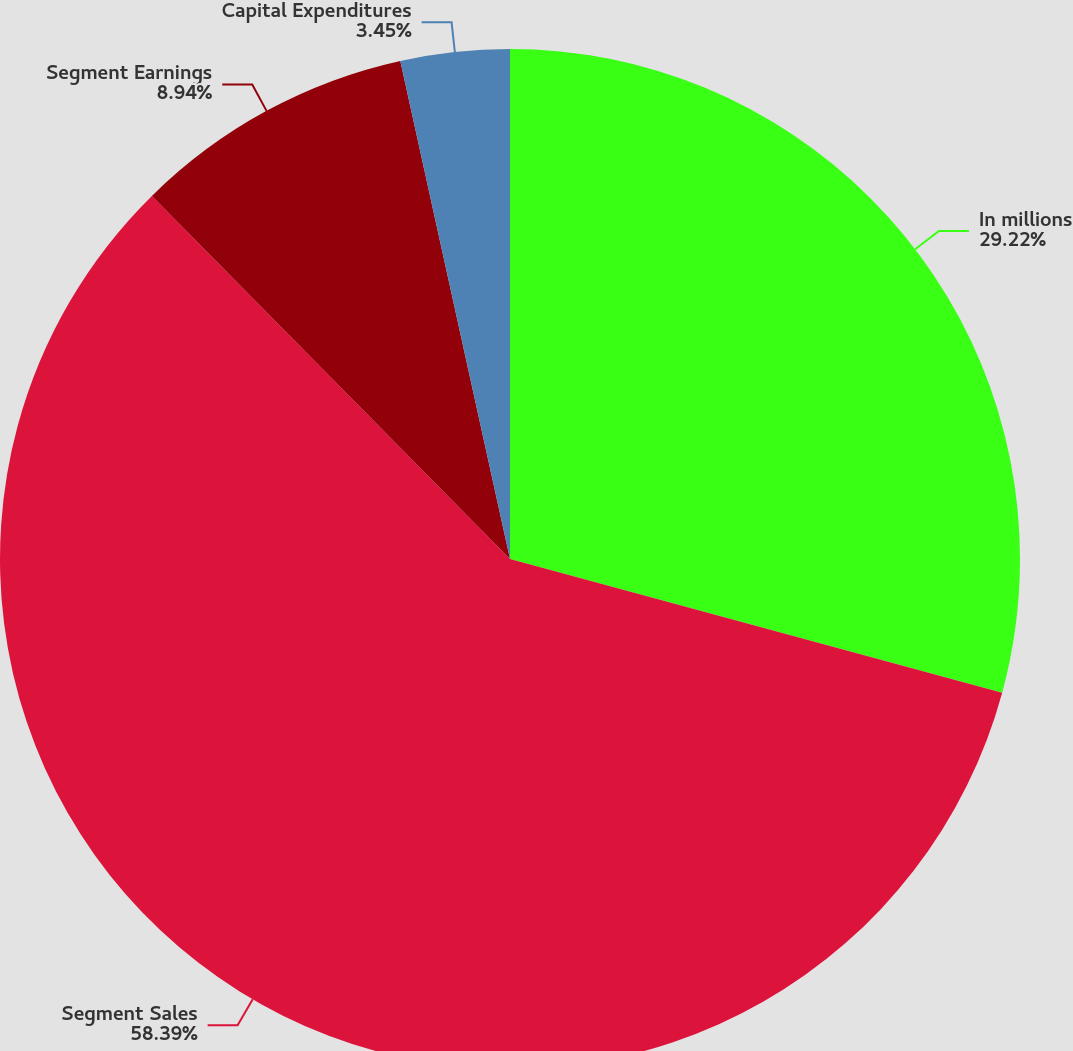<chart> <loc_0><loc_0><loc_500><loc_500><pie_chart><fcel>In millions<fcel>Segment Sales<fcel>Segment Earnings<fcel>Capital Expenditures<nl><fcel>29.22%<fcel>58.39%<fcel>8.94%<fcel>3.45%<nl></chart> 